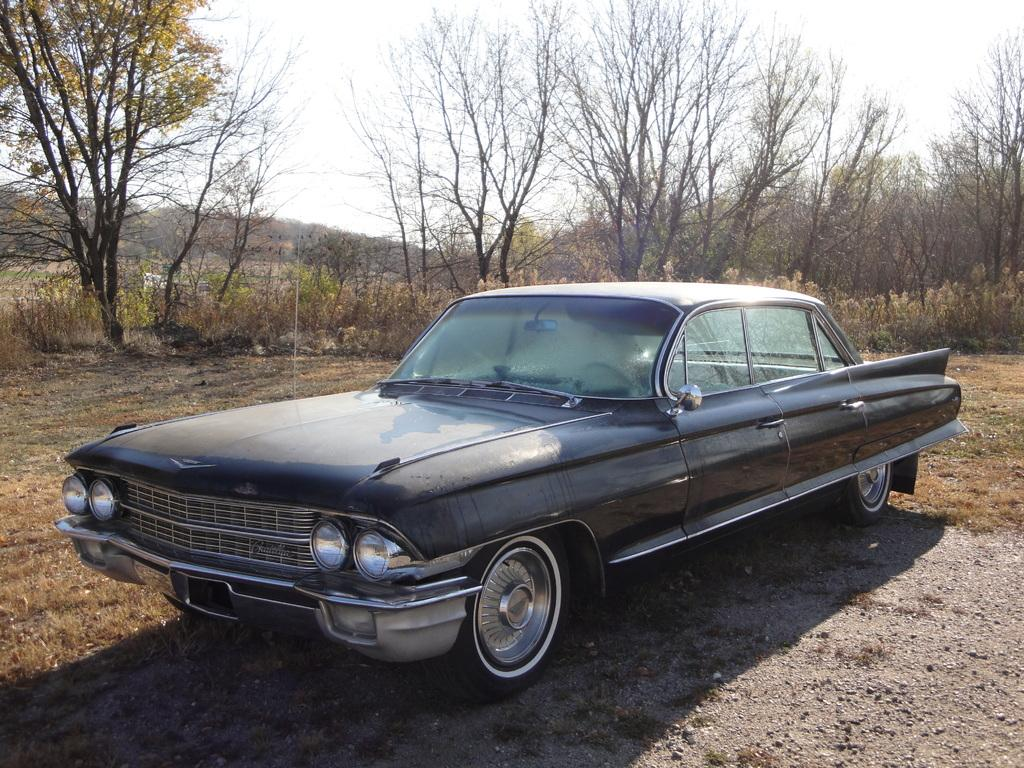What color is the car in the image? The car in the image is black. What can be seen in the background of the image? There are trees, grass, and the sky visible in the background of the image. Where is the white color object located in the image? The white color object is on the left side of the image. How many plastic balls are bouncing around the car in the image? There are no plastic balls or any balls present in the image. 